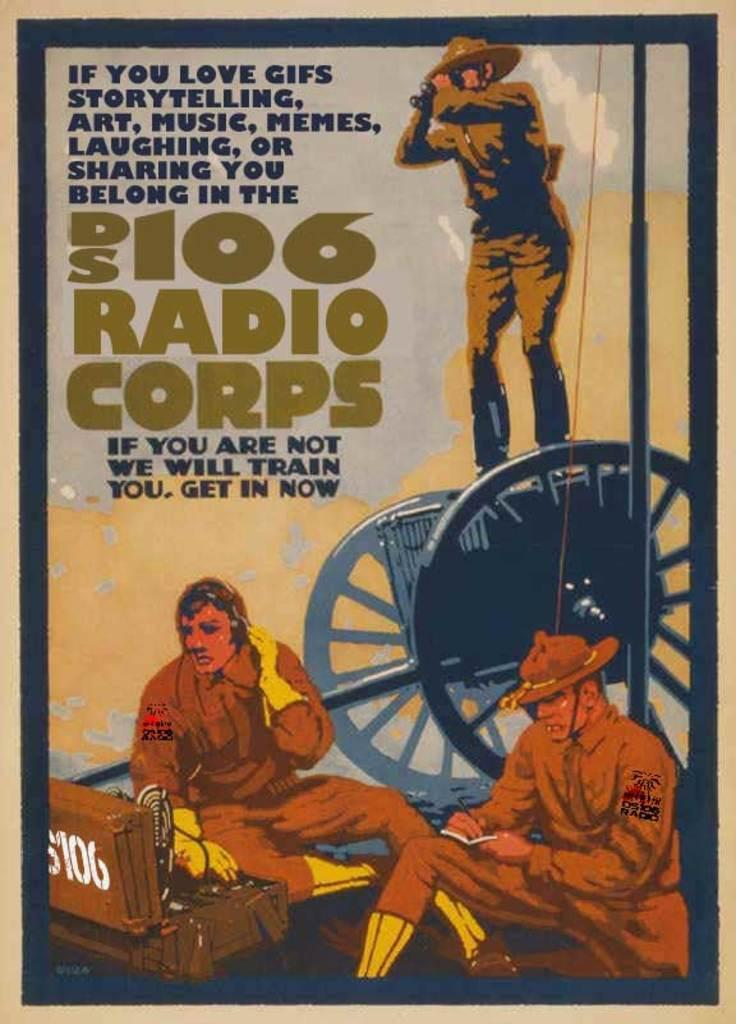<image>
Provide a brief description of the given image. A vintage looking advertisement for DS 106 Radio Corps. 